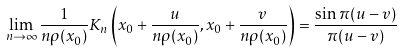<formula> <loc_0><loc_0><loc_500><loc_500>\lim _ { n \to \infty } \frac { 1 } { n \rho ( x _ { 0 } ) } K _ { n } \left ( x _ { 0 } + \frac { u } { n \rho ( x _ { 0 } ) } , x _ { 0 } + \frac { v } { n \rho ( x _ { 0 } ) } \right ) = \frac { \sin \pi ( u - v ) } { \pi ( u - v ) }</formula> 